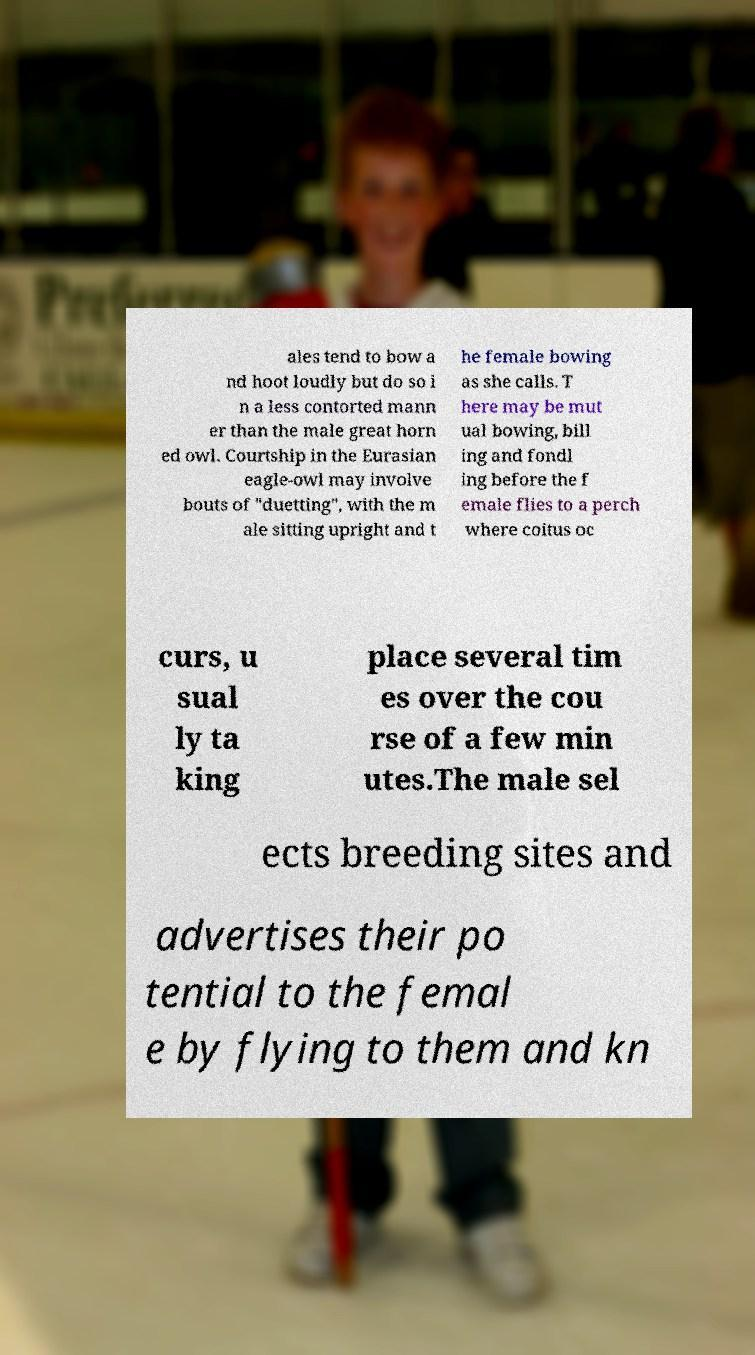Please read and relay the text visible in this image. What does it say? ales tend to bow a nd hoot loudly but do so i n a less contorted mann er than the male great horn ed owl. Courtship in the Eurasian eagle-owl may involve bouts of "duetting", with the m ale sitting upright and t he female bowing as she calls. T here may be mut ual bowing, bill ing and fondl ing before the f emale flies to a perch where coitus oc curs, u sual ly ta king place several tim es over the cou rse of a few min utes.The male sel ects breeding sites and advertises their po tential to the femal e by flying to them and kn 